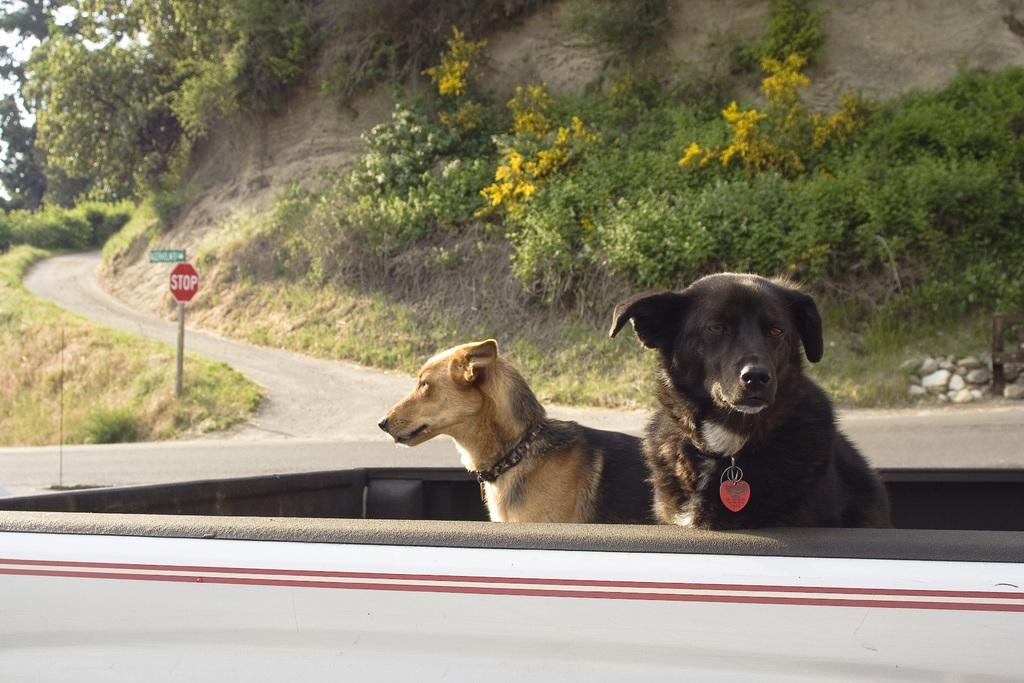What animals can be seen in the vehicle in the image? There are dogs in the vehicle in the center of the image. What type of natural scenery is visible in the background? There are trees in the background. What is located on the left side of the image? There is a sign board on the left side of the image. What type of man-made structure can be seen in the image? There is a road visible in the image. What type of wire is holding up the roof of the vehicle in the image? There is no wire or roof present in the image; it features a vehicle with dogs inside. 